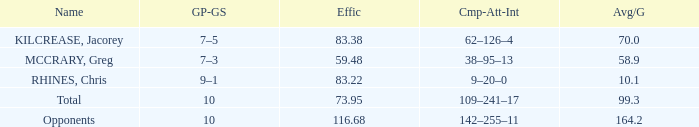What is the total avg/g of McCrary, Greg? 1.0. 